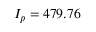Convert formula to latex. <formula><loc_0><loc_0><loc_500><loc_500>I _ { p } = 4 7 9 . 7 6</formula> 